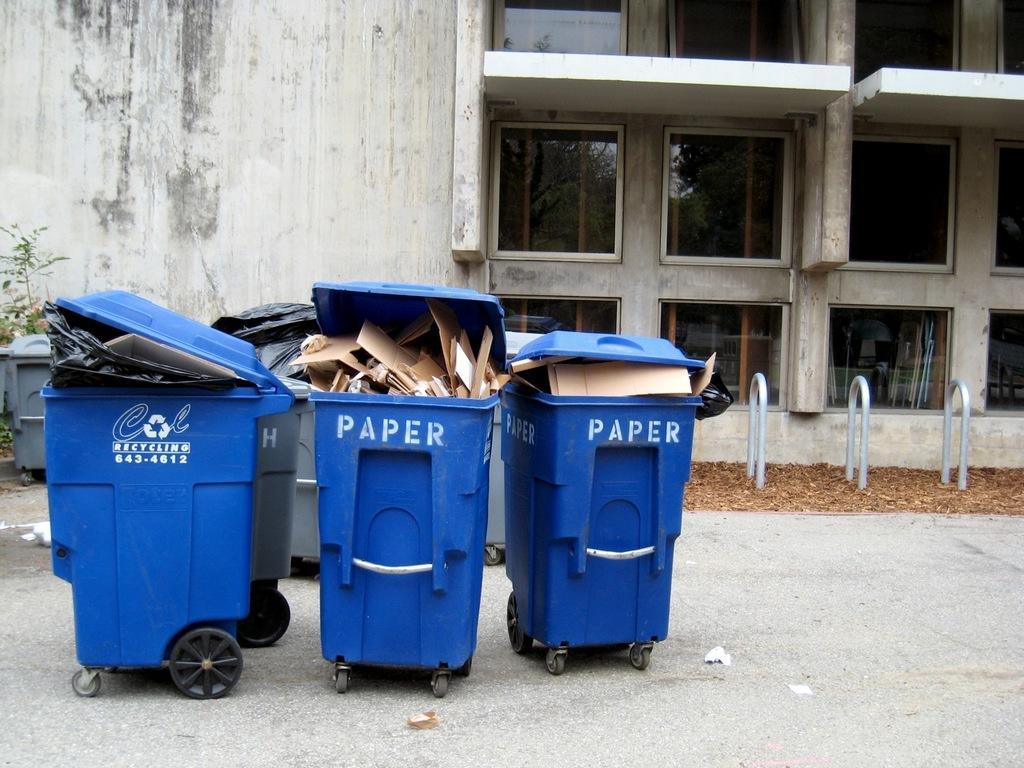Can you describe this image briefly? In this image we can see the trash bins with the wheels on the road. In the background we can see the building with the glass windows and also the wall. We can see the plant, the dried leaves and also the pipes. 